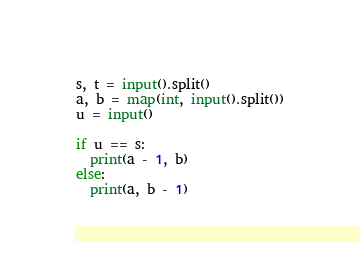<code> <loc_0><loc_0><loc_500><loc_500><_Python_>s, t = input().split()
a, b = map(int, input().split())
u = input()

if u == s:
  print(a - 1, b)
else:
  print(a, b - 1)</code> 